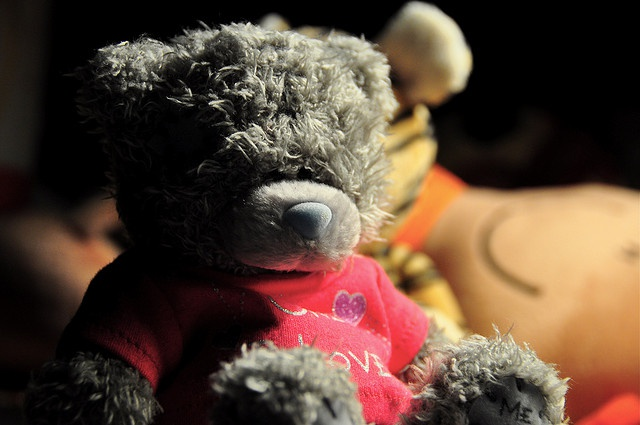Describe the objects in this image and their specific colors. I can see a teddy bear in black, darkgray, gray, and beige tones in this image. 